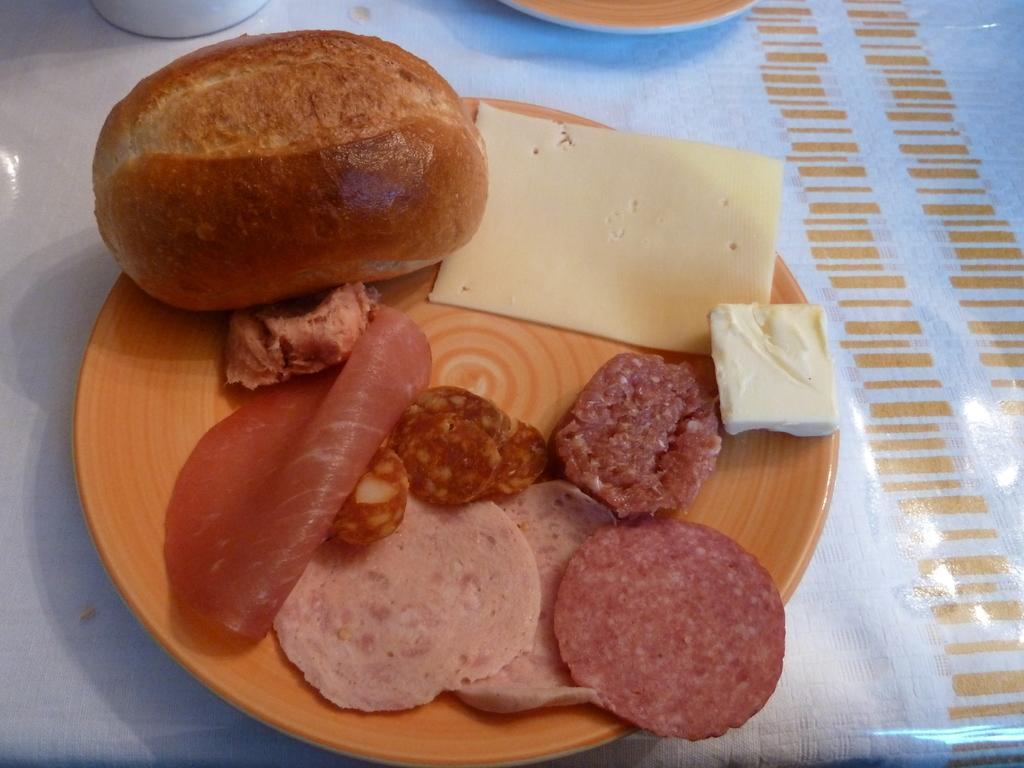What is on the plate that is visible in the image? There is a plate containing food in the image. Where is the plate located in the image? The plate is placed on a surface. What other dish can be seen at the top of the image? There is a bowl visible at the top of the image. Can you see a snail crawling on the plate in the image? No, there is no snail present in the image. What type of turkey is being served on the plate in the image? There is no turkey present in the image; it contains food, but the specific type of food is not mentioned. 